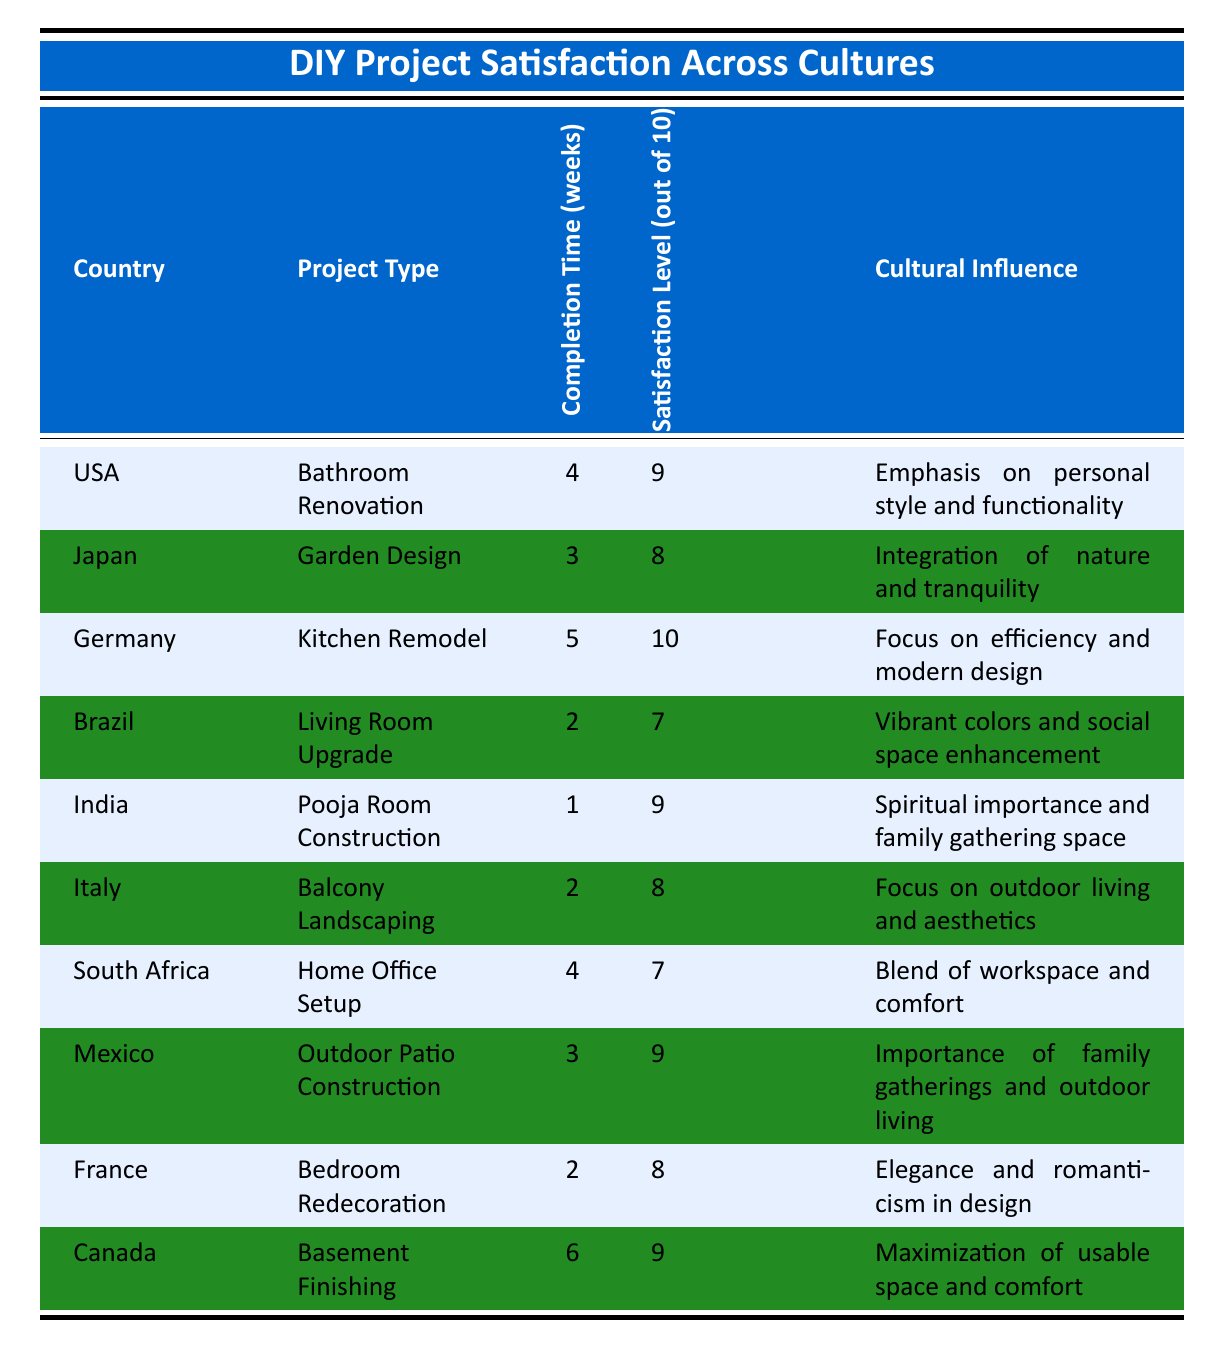What is the highest satisfaction level recorded in the table? The highest satisfaction level is represented by the value of 10 found in the row for Germany's Kitchen Remodel project.
Answer: 10 Which country reported a satisfaction level of 7? Brazil and South Africa both reported a satisfaction level of 7. This can be found by looking for the corresponding values in the Satisfaction Level column of their respective rows.
Answer: Brazil, South Africa What is the average satisfaction level across all countries listed? To calculate the average satisfaction level: sum the individual satisfaction levels (9 + 8 + 10 + 7 + 9 + 8 + 7 + 9 + 8 + 9 = 81) and divide by the number of entries (10), resulting in an average of 81/10 = 8.1.
Answer: 8.1 Did a project completion under 3 weeks achieve a satisfaction level of 9 or more? Yes, the Pooja Room Construction in India was completed in 1 week and had a satisfaction level of 9. This is verified by checking the Completion Time and Satisfaction Level columns.
Answer: Yes Which project type had the longest completion time and what was its satisfaction level? The Basement Finishing project in Canada had the longest completion time of 6 weeks, with a satisfaction level of 9. This is determined by examining the Completion Time column and finding the highest value.
Answer: Basement Finishing, 9 Is there any country where the project type had a satisfaction level of 10? Yes, Germany has a Kitchen Remodel project type with a satisfaction level of 10, as can be seen in the corresponding row.
Answer: Yes Which cultural influence aligns with an emphasis on outdoor living and aesthetics? The cultural influence associated with outdoor living and aesthetics is found in the row for Italy's Balcony Landscaping project.
Answer: Italy, Balcony Landscaping How many countries had a satisfaction level of 8 or higher? There are 6 countries (USA, Germany, India, Mexico, Italy, and Canada) that reported a satisfaction level of 8 or higher. This was found by counting the rows where the satisfaction level was 8 or above.
Answer: 6 Which project type in South Africa had a satisfaction level lower than the average satisfaction level across all countries? The Home Office Setup in South Africa had a satisfaction level of 7, which is lower than the average level of 8.1 calculated earlier.
Answer: Home Office Setup, 7 